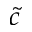<formula> <loc_0><loc_0><loc_500><loc_500>\tilde { c }</formula> 